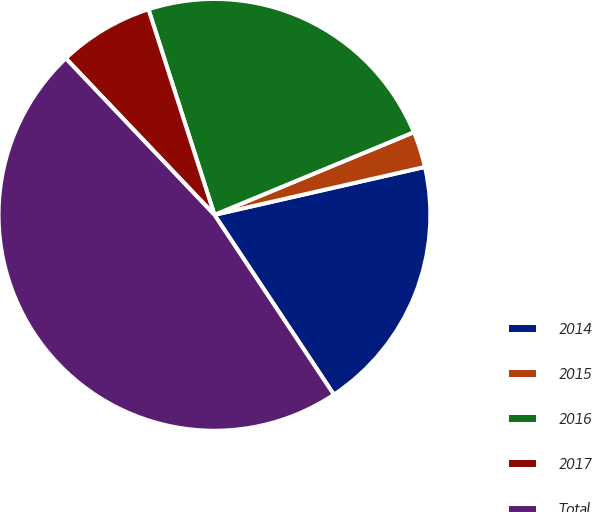Convert chart to OTSL. <chart><loc_0><loc_0><loc_500><loc_500><pie_chart><fcel>2014<fcel>2015<fcel>2016<fcel>2017<fcel>Total<nl><fcel>19.23%<fcel>2.69%<fcel>23.69%<fcel>7.15%<fcel>47.24%<nl></chart> 